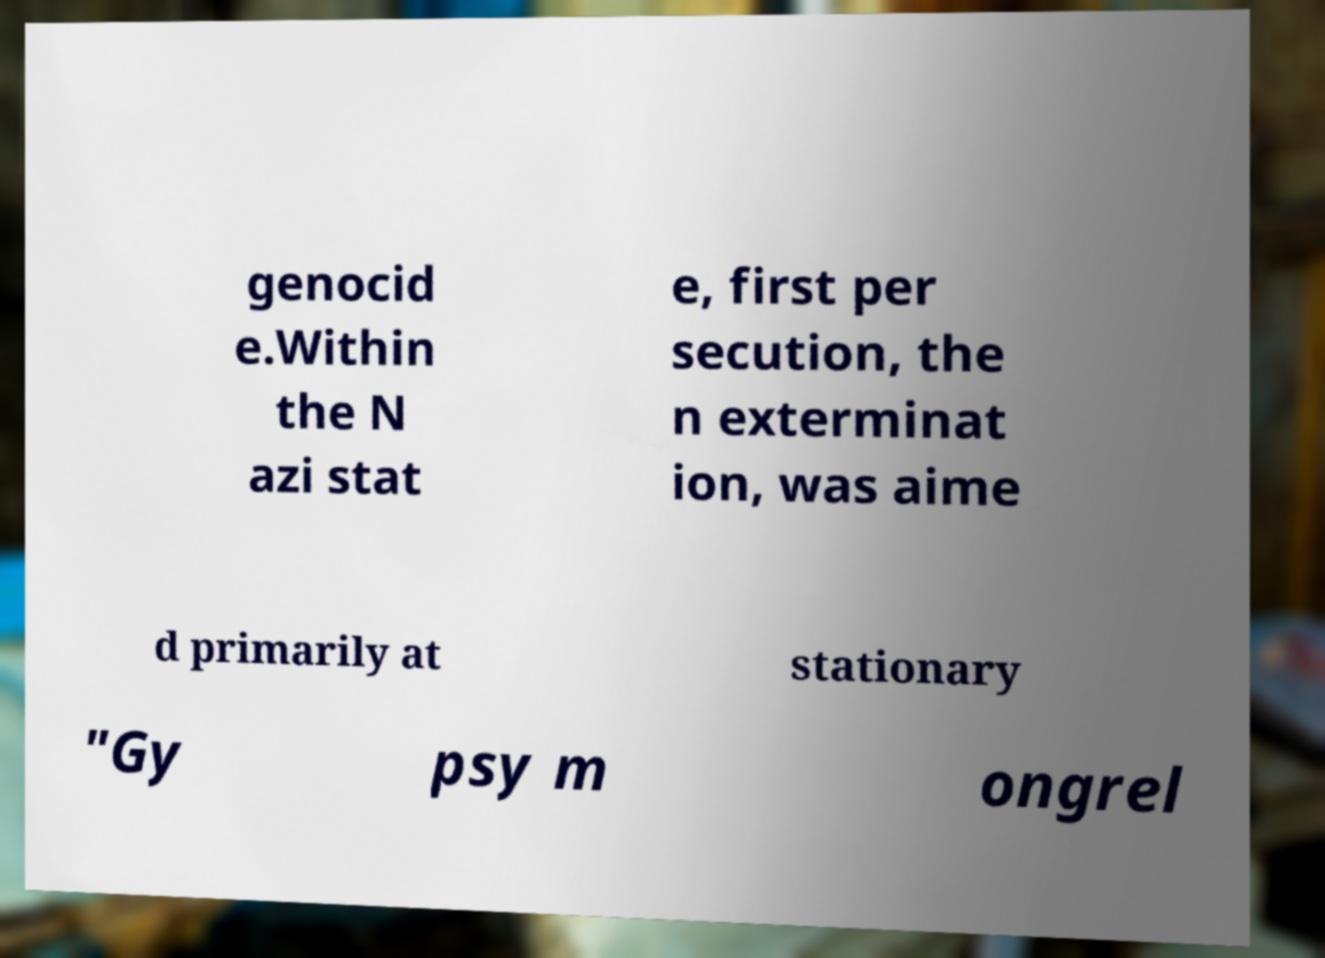Can you accurately transcribe the text from the provided image for me? genocid e.Within the N azi stat e, first per secution, the n exterminat ion, was aime d primarily at stationary "Gy psy m ongrel 